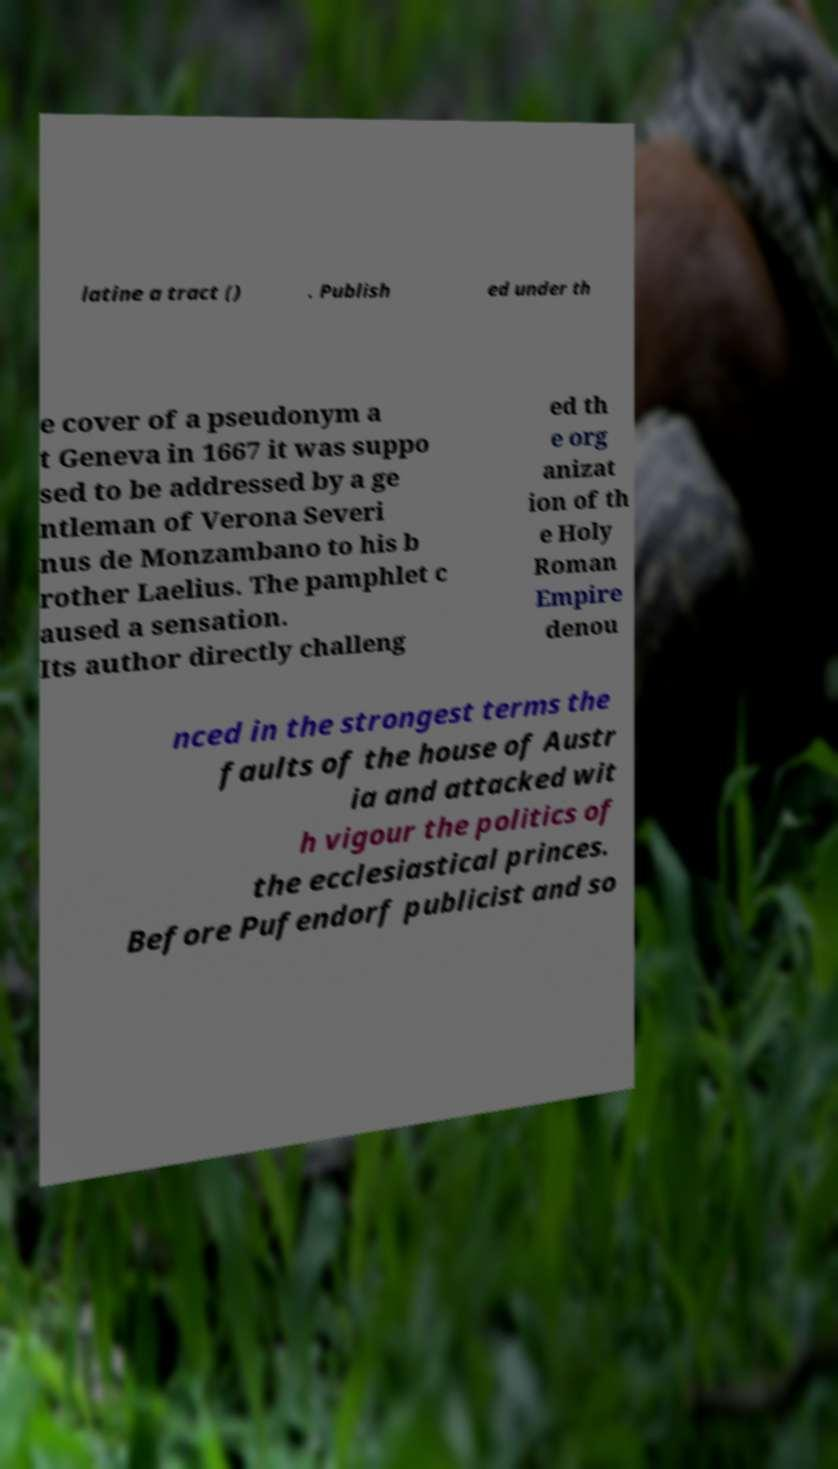I need the written content from this picture converted into text. Can you do that? latine a tract () . Publish ed under th e cover of a pseudonym a t Geneva in 1667 it was suppo sed to be addressed by a ge ntleman of Verona Severi nus de Monzambano to his b rother Laelius. The pamphlet c aused a sensation. Its author directly challeng ed th e org anizat ion of th e Holy Roman Empire denou nced in the strongest terms the faults of the house of Austr ia and attacked wit h vigour the politics of the ecclesiastical princes. Before Pufendorf publicist and so 